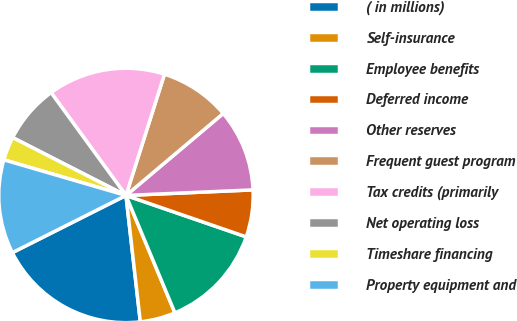<chart> <loc_0><loc_0><loc_500><loc_500><pie_chart><fcel>( in millions)<fcel>Self-insurance<fcel>Employee benefits<fcel>Deferred income<fcel>Other reserves<fcel>Frequent guest program<fcel>Tax credits (primarily<fcel>Net operating loss<fcel>Timeshare financing<fcel>Property equipment and<nl><fcel>19.38%<fcel>4.49%<fcel>13.43%<fcel>5.98%<fcel>10.45%<fcel>8.96%<fcel>14.91%<fcel>7.47%<fcel>3.0%<fcel>11.94%<nl></chart> 